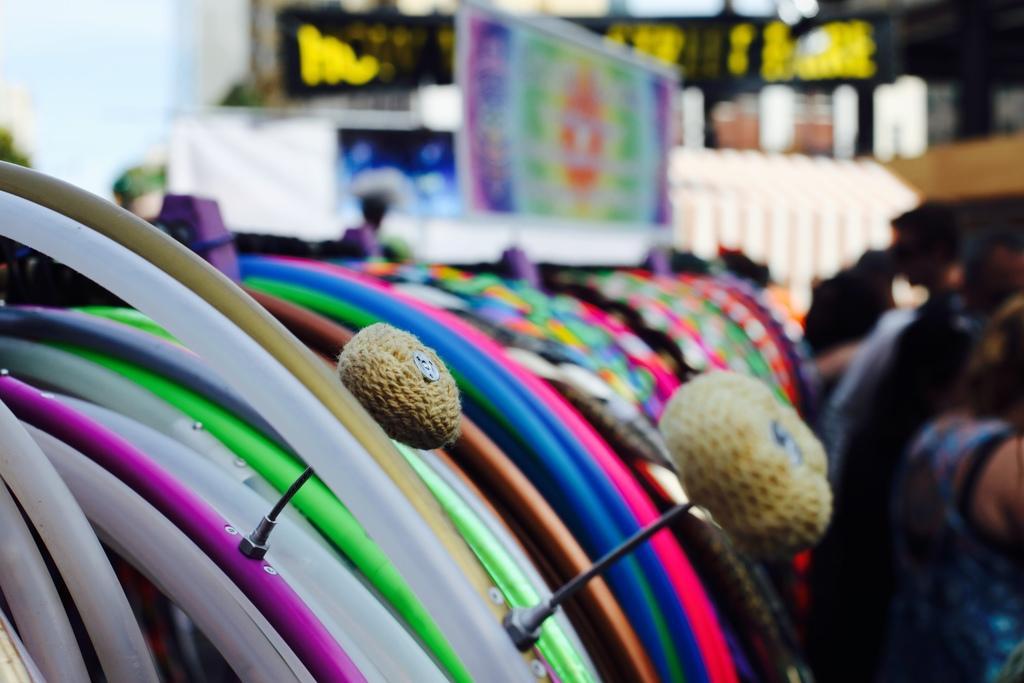How would you summarize this image in a sentence or two? This is zoom-in picture of circle shaped thing which are in different color. Right side of the image one lady is there. 